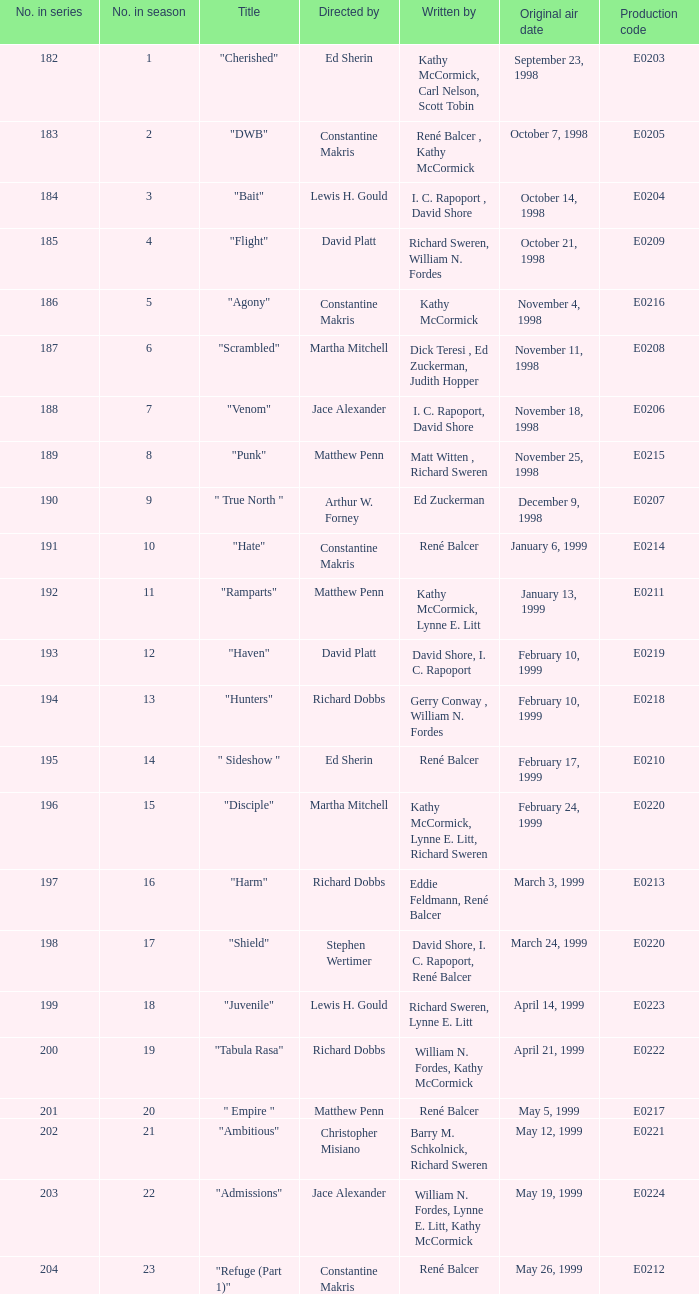Can you give me this table as a dict? {'header': ['No. in series', 'No. in season', 'Title', 'Directed by', 'Written by', 'Original air date', 'Production code'], 'rows': [['182', '1', '"Cherished"', 'Ed Sherin', 'Kathy McCormick, Carl Nelson, Scott Tobin', 'September 23, 1998', 'E0203'], ['183', '2', '"DWB"', 'Constantine Makris', 'René Balcer , Kathy McCormick', 'October 7, 1998', 'E0205'], ['184', '3', '"Bait"', 'Lewis H. Gould', 'I. C. Rapoport , David Shore', 'October 14, 1998', 'E0204'], ['185', '4', '"Flight"', 'David Platt', 'Richard Sweren, William N. Fordes', 'October 21, 1998', 'E0209'], ['186', '5', '"Agony"', 'Constantine Makris', 'Kathy McCormick', 'November 4, 1998', 'E0216'], ['187', '6', '"Scrambled"', 'Martha Mitchell', 'Dick Teresi , Ed Zuckerman, Judith Hopper', 'November 11, 1998', 'E0208'], ['188', '7', '"Venom"', 'Jace Alexander', 'I. C. Rapoport, David Shore', 'November 18, 1998', 'E0206'], ['189', '8', '"Punk"', 'Matthew Penn', 'Matt Witten , Richard Sweren', 'November 25, 1998', 'E0215'], ['190', '9', '" True North "', 'Arthur W. Forney', 'Ed Zuckerman', 'December 9, 1998', 'E0207'], ['191', '10', '"Hate"', 'Constantine Makris', 'René Balcer', 'January 6, 1999', 'E0214'], ['192', '11', '"Ramparts"', 'Matthew Penn', 'Kathy McCormick, Lynne E. Litt', 'January 13, 1999', 'E0211'], ['193', '12', '"Haven"', 'David Platt', 'David Shore, I. C. Rapoport', 'February 10, 1999', 'E0219'], ['194', '13', '"Hunters"', 'Richard Dobbs', 'Gerry Conway , William N. Fordes', 'February 10, 1999', 'E0218'], ['195', '14', '" Sideshow "', 'Ed Sherin', 'René Balcer', 'February 17, 1999', 'E0210'], ['196', '15', '"Disciple"', 'Martha Mitchell', 'Kathy McCormick, Lynne E. Litt, Richard Sweren', 'February 24, 1999', 'E0220'], ['197', '16', '"Harm"', 'Richard Dobbs', 'Eddie Feldmann, René Balcer', 'March 3, 1999', 'E0213'], ['198', '17', '"Shield"', 'Stephen Wertimer', 'David Shore, I. C. Rapoport, René Balcer', 'March 24, 1999', 'E0220'], ['199', '18', '"Juvenile"', 'Lewis H. Gould', 'Richard Sweren, Lynne E. Litt', 'April 14, 1999', 'E0223'], ['200', '19', '"Tabula Rasa"', 'Richard Dobbs', 'William N. Fordes, Kathy McCormick', 'April 21, 1999', 'E0222'], ['201', '20', '" Empire "', 'Matthew Penn', 'René Balcer', 'May 5, 1999', 'E0217'], ['202', '21', '"Ambitious"', 'Christopher Misiano', 'Barry M. Schkolnick, Richard Sweren', 'May 12, 1999', 'E0221'], ['203', '22', '"Admissions"', 'Jace Alexander', 'William N. Fordes, Lynne E. Litt, Kathy McCormick', 'May 19, 1999', 'E0224'], ['204', '23', '"Refuge (Part 1)"', 'Constantine Makris', 'René Balcer', 'May 26, 1999', 'E0212']]} What is the season number of the episode written by Matt Witten , Richard Sweren? 8.0. 